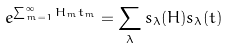Convert formula to latex. <formula><loc_0><loc_0><loc_500><loc_500>e ^ { \sum _ { m = 1 } ^ { \infty } H _ { m } t _ { m } } = \sum _ { \lambda } s _ { \lambda } ( { H } ) s _ { \lambda } ( { t } )</formula> 